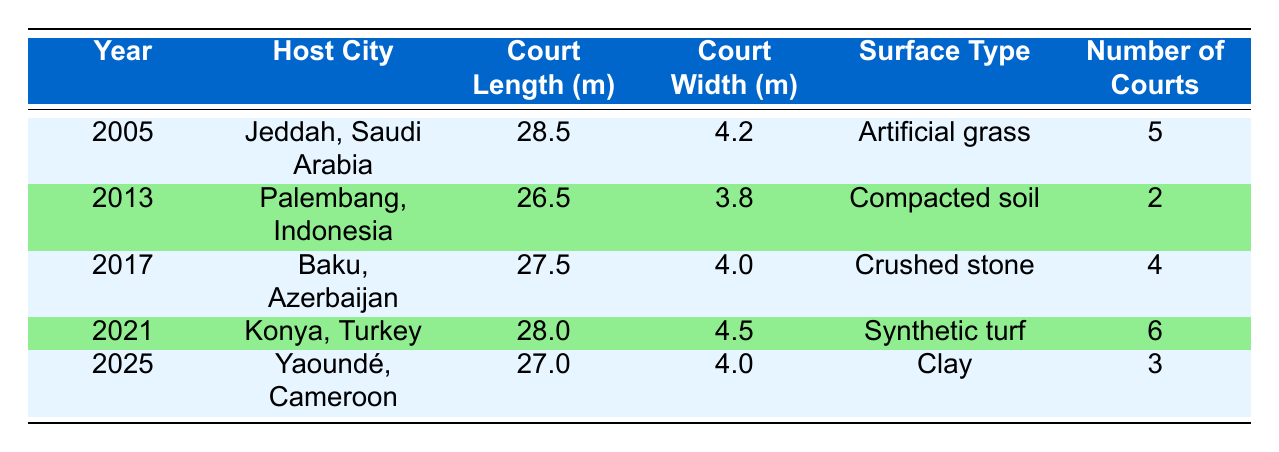What is the court length in Jeddah, Saudi Arabia? The table shows that in Jeddah, Saudi Arabia (year 2005), the court length is reported as 28.5 meters.
Answer: 28.5 Which venue has the widest court? To determine the widest court, I look at the court widths listed: 4.2 (Jeddah), 3.8 (Palembang), 4.0 (Baku, Yaoundé), and 4.5 (Konya). The widest court is in Konya, Turkey, with a width of 4.5 meters.
Answer: 4.5 How many courts were there in total across all venues in the table? The total number of courts can be found by adding the number of courts in each venue: 5 (Jeddah) + 2 (Palembang) + 4 (Baku) + 6 (Konya) + 3 (Yaoundé) = 20 courts total.
Answer: 20 Is there a venue with clay surface type? Yes, in Yaoundé, Cameroon (year 2025), the surface type is clay, as indicated in the table.
Answer: Yes What is the average court length across the listed venues? I first sum the court lengths: 28.5 (Jeddah) + 26.5 (Palembang) + 27.5 (Baku) + 28.0 (Konya) + 27.0 (Yaoundé) = 137.5 meters. Then I divide by the number of venues, which is 5. The average is 137.5 / 5 = 27.5 meters.
Answer: 27.5 Which venue has the least number of courts? By examining the number of courts, I can see that Palembang, Indonesia has the least number with only 2 courts listed in the table.
Answer: 2 Find the venue with the court length closest to 27 meters. Looking at the court lengths, the values are 26.5, 27.0, 27.5, 28.0, and 28.5 meters. The lengths closest to 27 meters are 27.0 (Yaoundé) and 27.5 (Baku). Yaoundé is the closest as it is 27.0 meters.
Answer: Yaoundé, Cameroon How does the number of courts in 2021 compare to the number in 2005? In 2021, there were 6 courts in Konya, Turkey, while in 2005, there were 5 courts in Jeddah, Saudi Arabia. Comparing these, 6 is greater than 5, so there is one more court in 2021 than in 2005.
Answer: 1 more court in 2021 Is the surface type in Palembang the same as in Baku? No, the surface type in Palembang (Compacted soil) is different from that in Baku (Crushed stone) according to the table.
Answer: No 